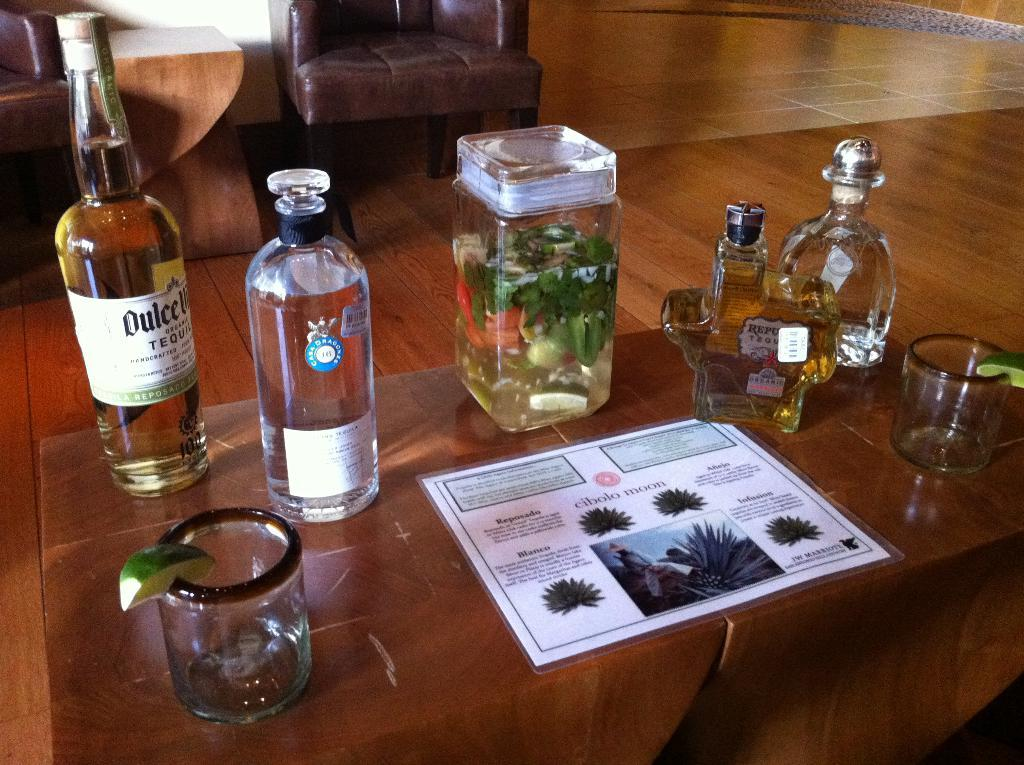What type of setting is depicted in the image? The image is an indoor view. What objects can be seen in the image? There are bottles, a glass, a lemon, and a card in the image. What type of furniture is present in the image? There is a wooden table and a chair in the image. What is the flooring material in the image? The floor has tiles. Can you describe the other table in the image? There is another table on the left side of the image. How many dolls are sitting on the stick in the image? There are no dolls or sticks present in the image. 